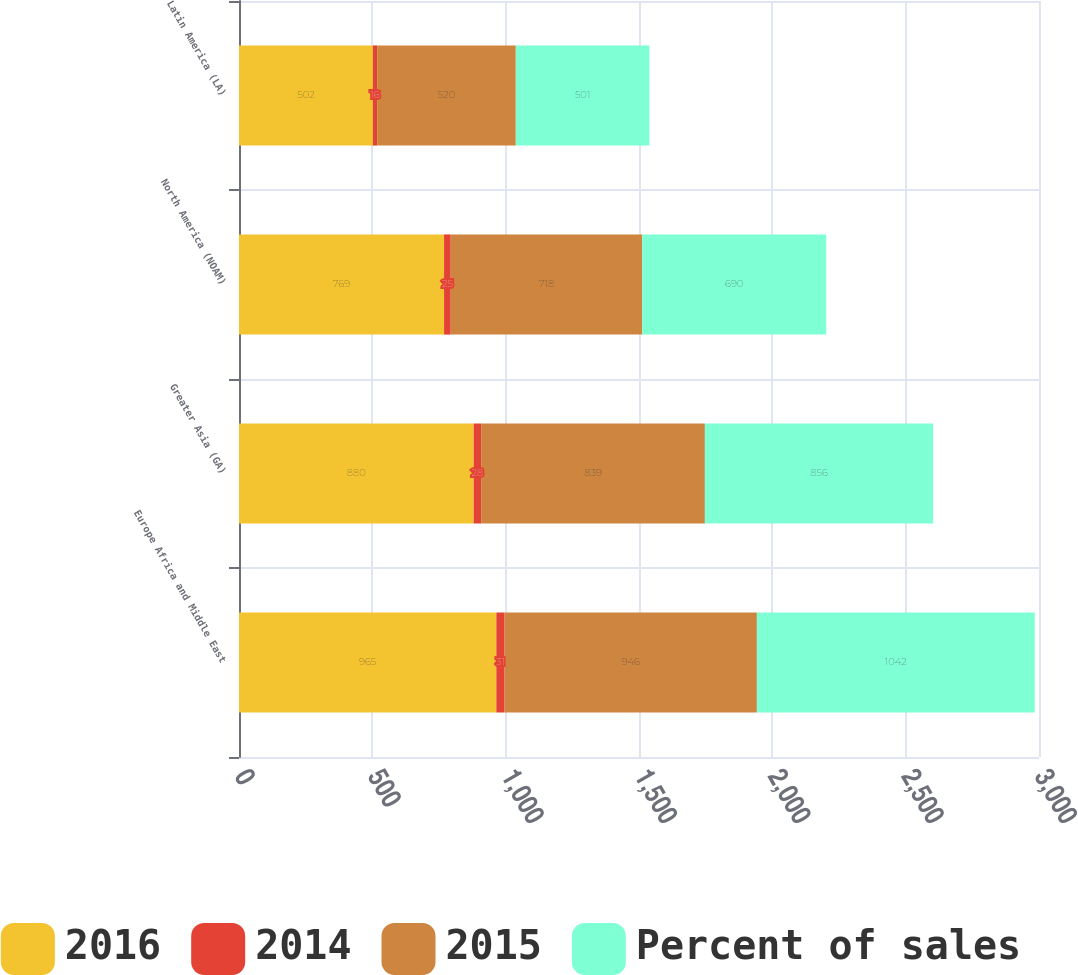Convert chart to OTSL. <chart><loc_0><loc_0><loc_500><loc_500><stacked_bar_chart><ecel><fcel>Europe Africa and Middle East<fcel>Greater Asia (GA)<fcel>North America (NOAM)<fcel>Latin America (LA)<nl><fcel>2016<fcel>965<fcel>880<fcel>769<fcel>502<nl><fcel>2014<fcel>31<fcel>28<fcel>25<fcel>16<nl><fcel>2015<fcel>946<fcel>839<fcel>718<fcel>520<nl><fcel>Percent of sales<fcel>1042<fcel>856<fcel>690<fcel>501<nl></chart> 